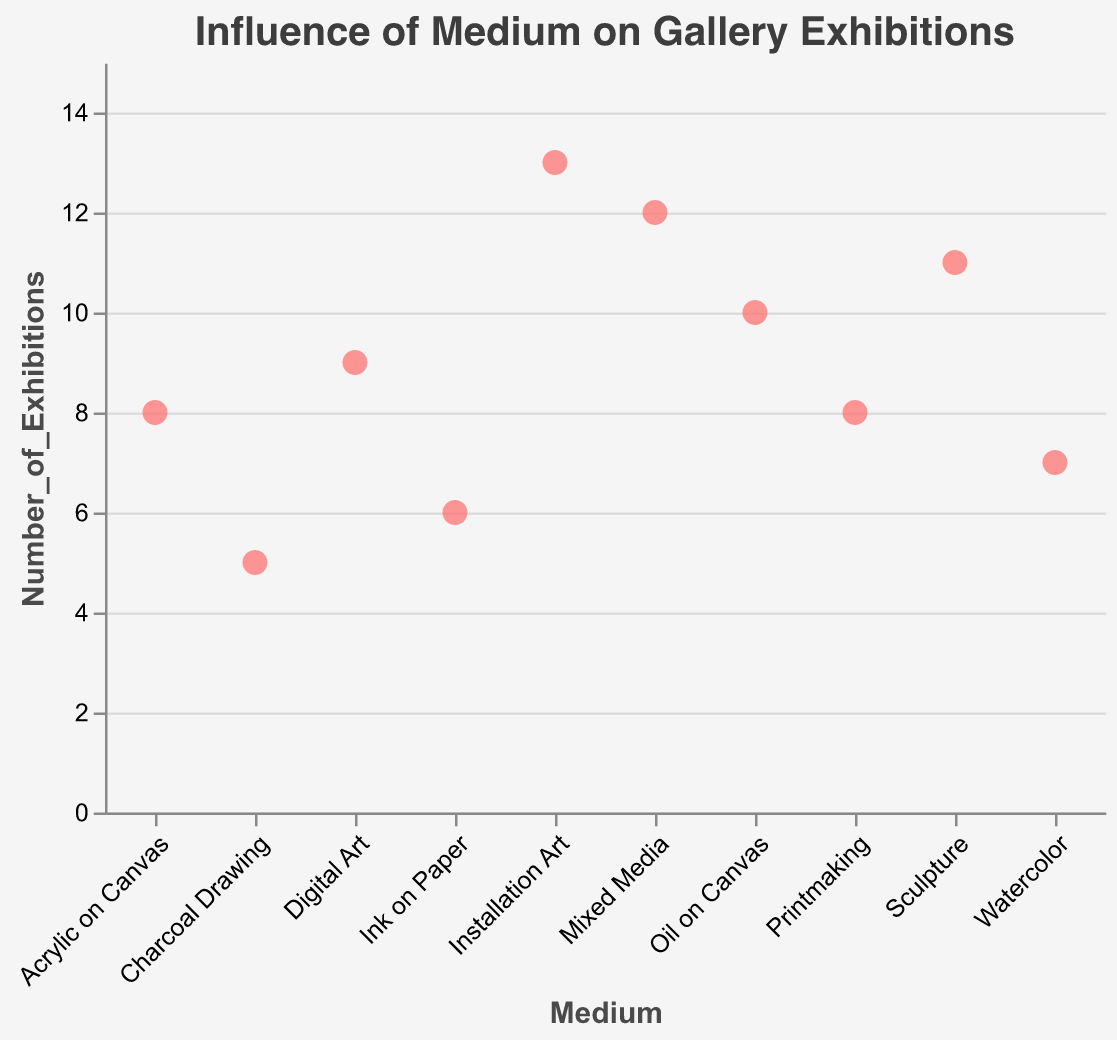What is the title of the plot? The title of the plot is displayed at the top of the figure. It reads "Influence of Medium on Gallery Exhibitions."
Answer: Influence of Medium on Gallery Exhibitions How many exhibitions does "Charcoal Drawing" have? Locate the data point for "Charcoal Drawing" on the x-axis. Its corresponding y-value indicates the number of exhibitions, which is 5.
Answer: 5 Which medium has the highest number of exhibitions? Scan the y-values to find the data point with the highest value. "Installation Art" has the highest number with 13 exhibitions.
Answer: Installation Art What is the range of the number of exhibitions? Find the lowest and highest y-values. The lowest is 5 ("Charcoal Drawing") and the highest is 13 ("Installation Art"). The range is 13 - 5 = 8.
Answer: 8 What is the average number of exhibitions for "Oil on Canvas," "Acrylic on Canvas," and "Watercolor"? Sum the number of exhibitions for these mediums: 10 (Oil on Canvas) + 8 (Acrylic on Canvas) + 7 (Watercolor) = 25. Divide by 3 to find the average: 25 / 3 ≈ 8.33.
Answer: 8.33 Which mediums have fewer than 7 exhibitions? Identify data points with y-values less than 7: "Charcoal Drawing" (5) and "Ink on Paper" (6).
Answer: Charcoal Drawing, Ink on Paper How many mediums have exactly 8 exhibitions? Count the data points with y-values equal to 8: "Acrylic on Canvas" and "Printmaking." There are 2 mediums.
Answer: 2 What is the difference in the number of exhibitions between "Sculpture" and "Watercolor"? Find the y-values for both mediums: "Sculpture" has 11 and "Watercolor" has 7. The difference is 11 - 7 = 4.
Answer: 4 How does "Mixed Media" compare to "Digital Art" in terms of exhibitions? Compare the y-values: "Mixed Media" has 12 exhibitions, and "Digital Art" has 9. "Mixed Media" has more exhibitions.
Answer: Mixed Media has more Which medium has the closest number of exhibitions to "Oil on Canvas"? Compare the y-value of "Oil on Canvas" (10) to other mediums: "Installation Art" has 13, "Mixed Media" has 12, "Sculpture" has 11. The closest is "Sculpture" with 11 exhibitions, which is only 1 more.
Answer: Sculpture 